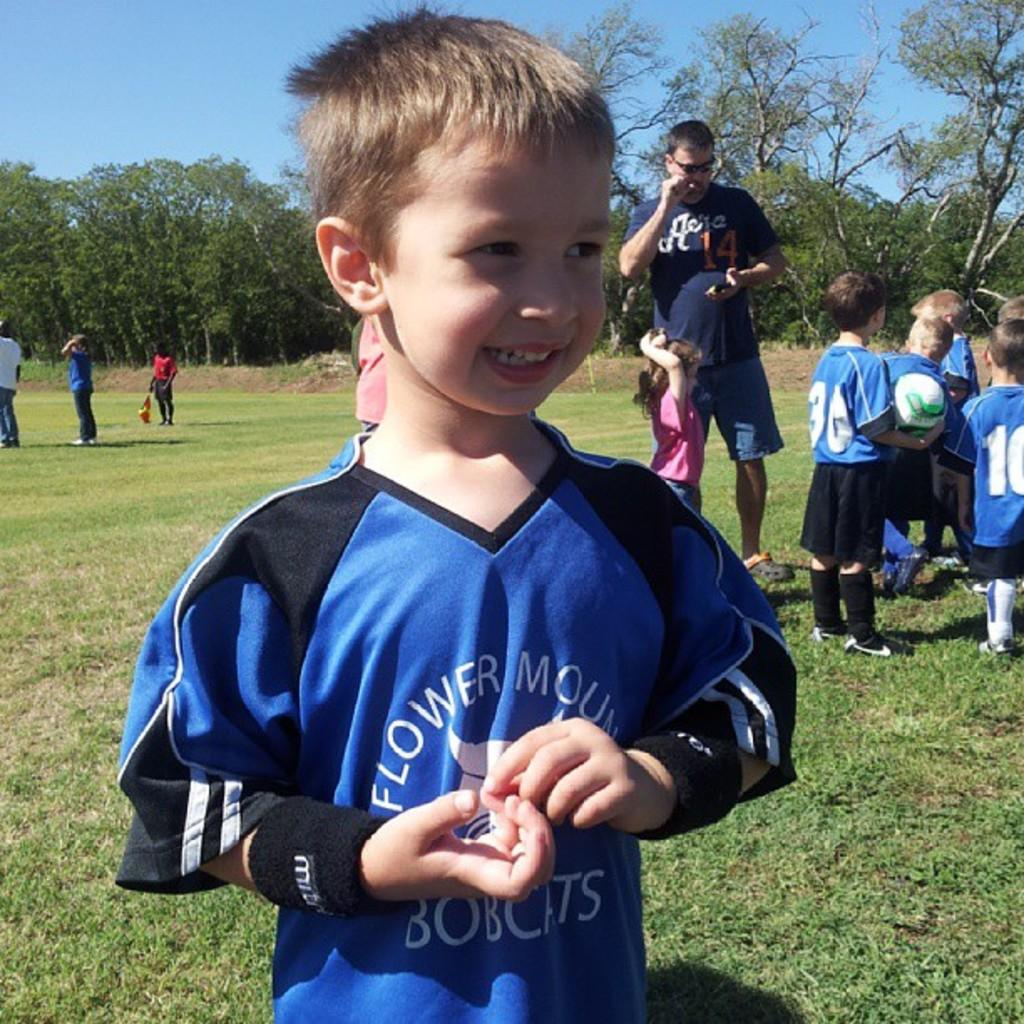<image>
Share a concise interpretation of the image provided. A group of kids wear jerseys identifying them as Bobcats. 